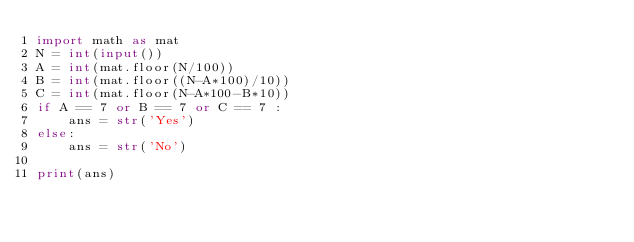<code> <loc_0><loc_0><loc_500><loc_500><_Python_>import math as mat
N = int(input())
A = int(mat.floor(N/100))
B = int(mat.floor((N-A*100)/10))
C = int(mat.floor(N-A*100-B*10))
if A == 7 or B == 7 or C == 7 :
    ans = str('Yes')
else:
    ans = str('No')

print(ans)</code> 